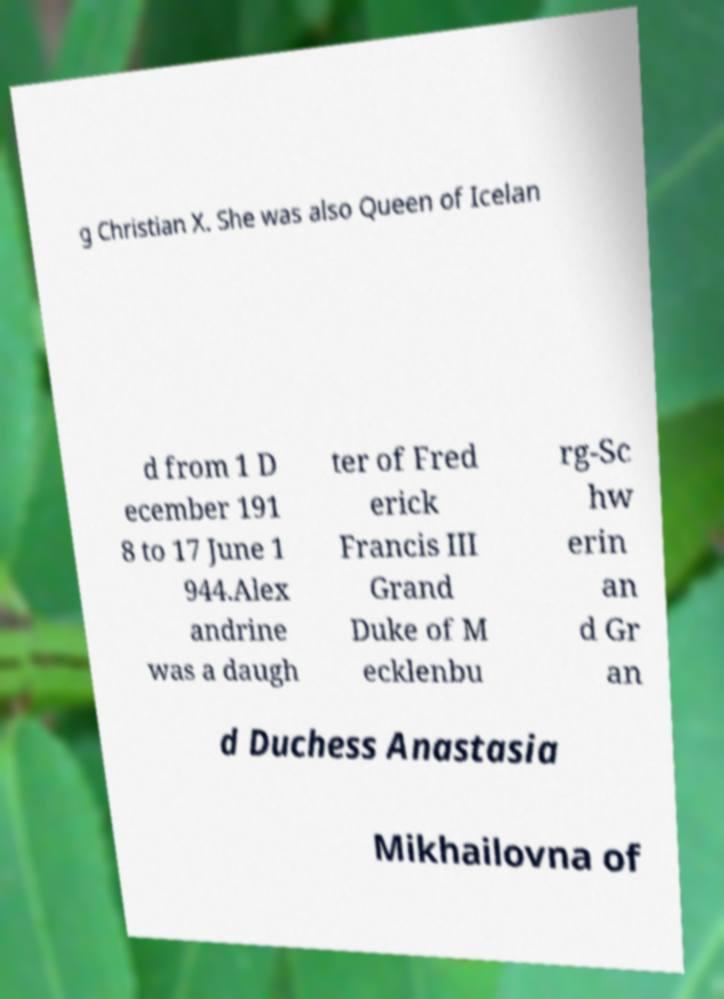Please read and relay the text visible in this image. What does it say? g Christian X. She was also Queen of Icelan d from 1 D ecember 191 8 to 17 June 1 944.Alex andrine was a daugh ter of Fred erick Francis III Grand Duke of M ecklenbu rg-Sc hw erin an d Gr an d Duchess Anastasia Mikhailovna of 